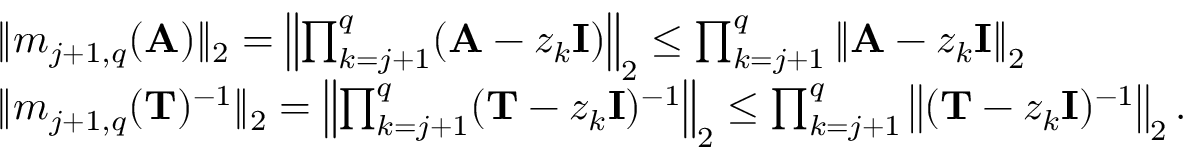<formula> <loc_0><loc_0><loc_500><loc_500>\begin{array} { r l } & { \| m _ { j + 1 , q } ( A ) \| _ { 2 } = \left \| \prod _ { k = j + 1 } ^ { q } ( A - z _ { k } I ) \right \| _ { 2 } \leq \prod _ { k = j + 1 } ^ { q } \left \| A - z _ { k } I \right \| _ { 2 } } \\ & { \| m _ { j + 1 , q } ( T ) ^ { - 1 } \| _ { 2 } = \left \| \prod _ { k = j + 1 } ^ { q } ( T - z _ { k } I ) ^ { - 1 } \right \| _ { 2 } \leq \prod _ { k = j + 1 } ^ { q } \left \| ( T - z _ { k } I ) ^ { - 1 } \right \| _ { 2 } . } \end{array}</formula> 